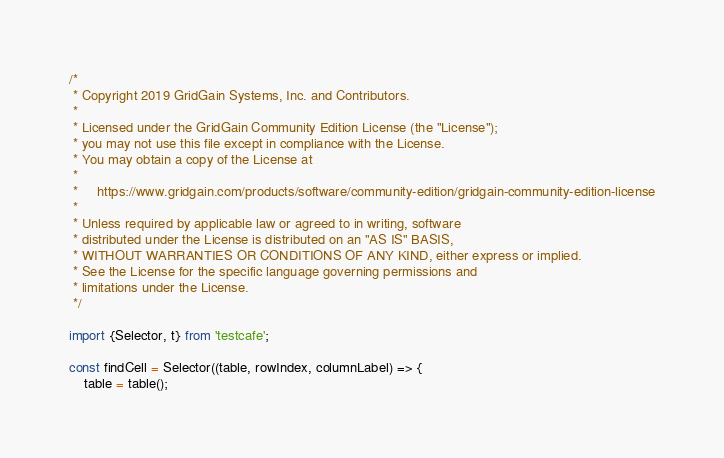Convert code to text. <code><loc_0><loc_0><loc_500><loc_500><_JavaScript_>/*
 * Copyright 2019 GridGain Systems, Inc. and Contributors.
 *
 * Licensed under the GridGain Community Edition License (the "License");
 * you may not use this file except in compliance with the License.
 * You may obtain a copy of the License at
 *
 *     https://www.gridgain.com/products/software/community-edition/gridgain-community-edition-license
 *
 * Unless required by applicable law or agreed to in writing, software
 * distributed under the License is distributed on an "AS IS" BASIS,
 * WITHOUT WARRANTIES OR CONDITIONS OF ANY KIND, either express or implied.
 * See the License for the specific language governing permissions and
 * limitations under the License.
 */

import {Selector, t} from 'testcafe';

const findCell = Selector((table, rowIndex, columnLabel) => {
    table = table();
</code> 